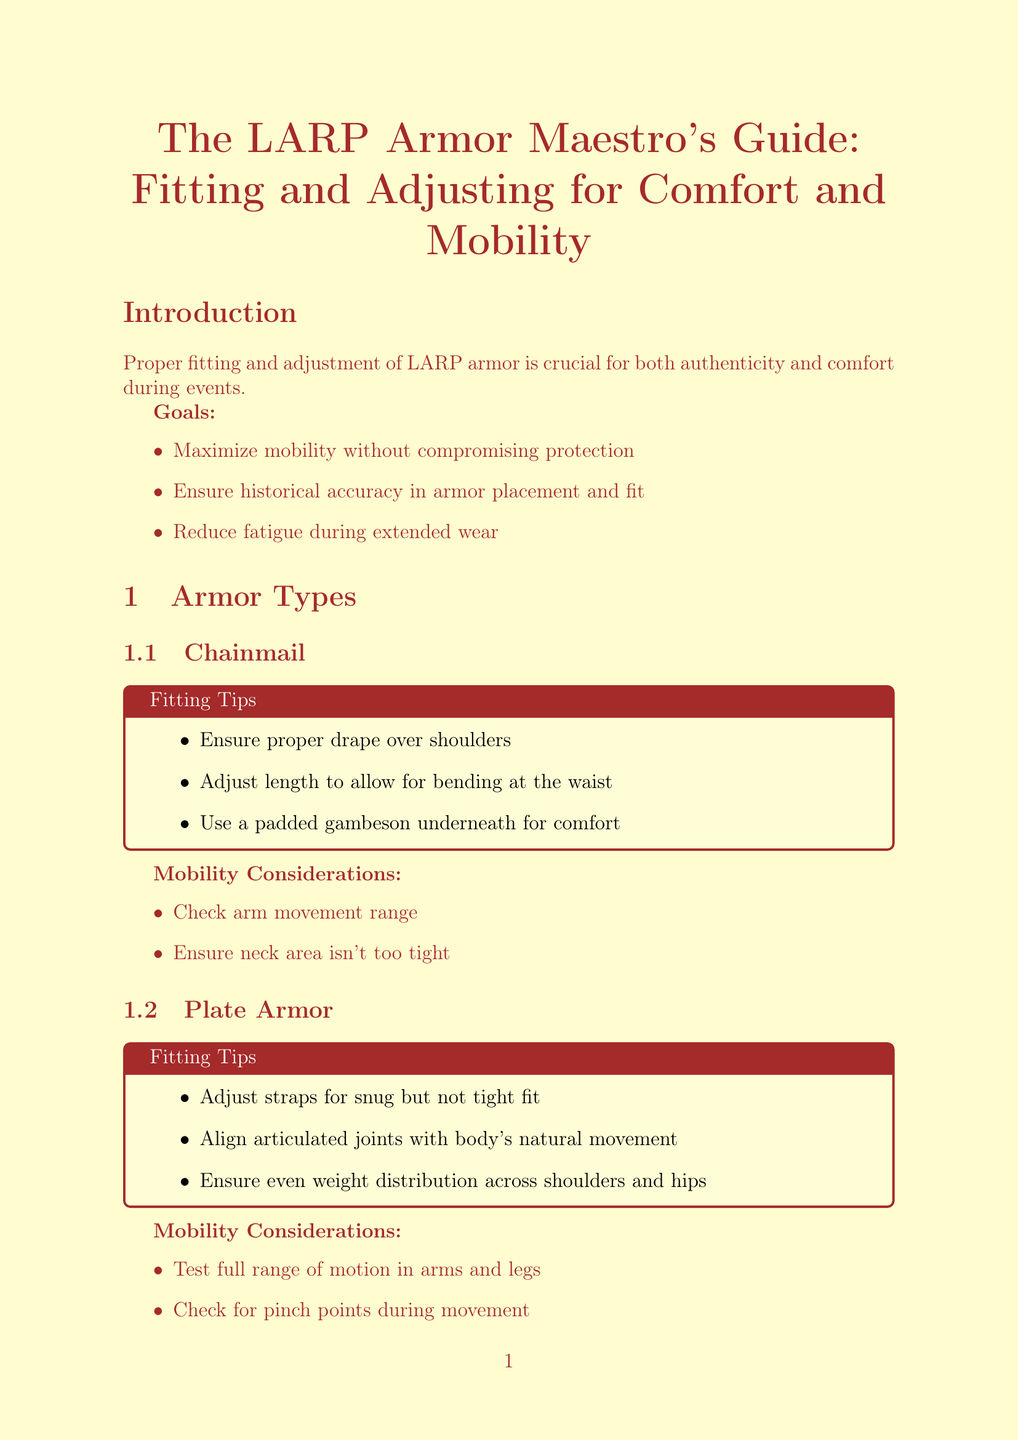What are the goals of proper armor fitting? The goals of proper armor fitting are stated in the introduction and include maximizing mobility, ensuring historical accuracy, and reducing fatigue.
Answer: Maximize mobility, ensure historical accuracy, reduce fatigue What tool is used for creating additional holes in straps? The adjustment tools section mentions specific tools and their uses, including one for making holes in straps.
Answer: Leather Punch What type of armor requires a padded gambeson underneath? The fitting tips for chainmail specifically mention the use of a padded gambeson for comfort.
Answer: Chainmail What items are recommended for comfort enhancement? The document lists specific items that enhance comfort during wear, including an arming cap and padded gauntlet inserts.
Answer: Arming Cap, Padded Gauntlet Inserts, Breathable Undergarments How should the straps of plate armor be adjusted? The fitting tips section for plate armor mentions how the straps should be in relation to fitting.
Answer: Snug but not tight fit What consideration is crucial for neck area fitting in chainmail? The mobility considerations for chainmail mention a specific aspect of the neck area that should be addressed during fitting.
Answer: Ensure neck area isn't too tight What is a benefit of using breathable undergarments? The comfort enhancements section outlines benefits associated with specific items, including one for undergarments.
Answer: Wicks away sweat and reduces overheating What is the importance of historical accuracy in armor fitting? Historical accuracy in armor fitting is elaborated in a specific section, emphasizing its role in immersion and respect.
Answer: Enhances immersion and respect among LARP peers 